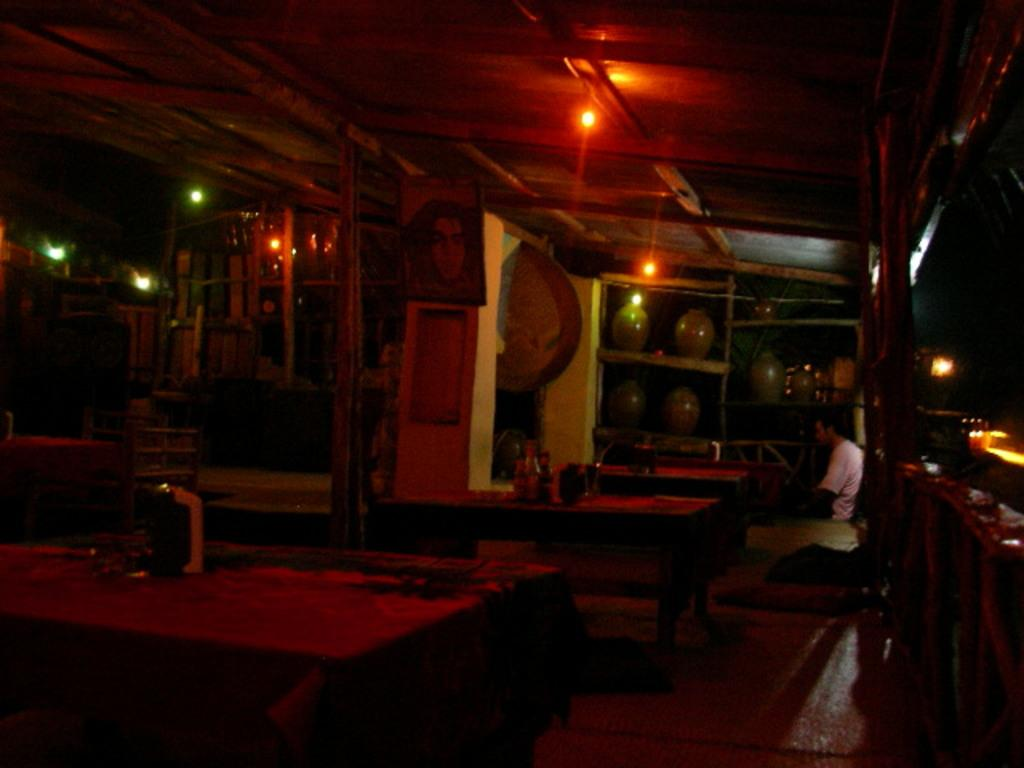What can be seen in the image that provides illumination? There are lights in the image. Who or what is sitting in the image? There is a person sitting in the image. What piece of furniture is present in the image? There is a table in the image. What type of silver is being used for the test in the image? There is no silver or test present in the image. How does the team interact with the person sitting in the image? There is no team present in the image; only a person sitting and lights can be seen. 